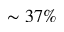Convert formula to latex. <formula><loc_0><loc_0><loc_500><loc_500>\sim 3 7 \%</formula> 